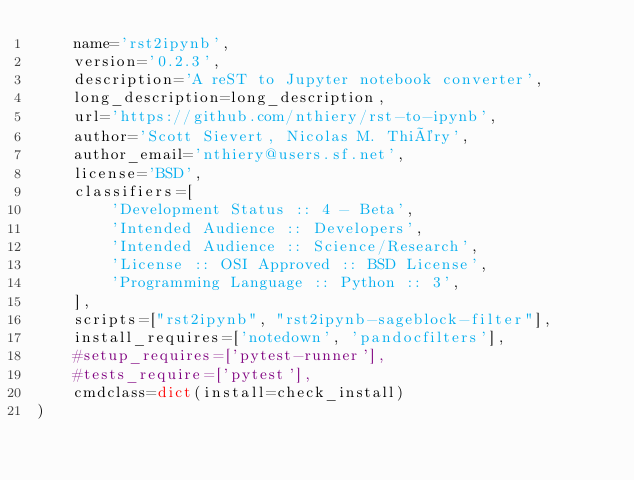Convert code to text. <code><loc_0><loc_0><loc_500><loc_500><_Python_>    name='rst2ipynb',
    version='0.2.3',
    description='A reST to Jupyter notebook converter',
    long_description=long_description,
    url='https://github.com/nthiery/rst-to-ipynb',
    author='Scott Sievert, Nicolas M. Thiéry',
    author_email='nthiery@users.sf.net',
    license='BSD',
    classifiers=[
        'Development Status :: 4 - Beta',
        'Intended Audience :: Developers',
        'Intended Audience :: Science/Research',
        'License :: OSI Approved :: BSD License',
        'Programming Language :: Python :: 3',
    ],
    scripts=["rst2ipynb", "rst2ipynb-sageblock-filter"],
    install_requires=['notedown', 'pandocfilters'],
    #setup_requires=['pytest-runner'],
    #tests_require=['pytest'],
    cmdclass=dict(install=check_install)
)
</code> 